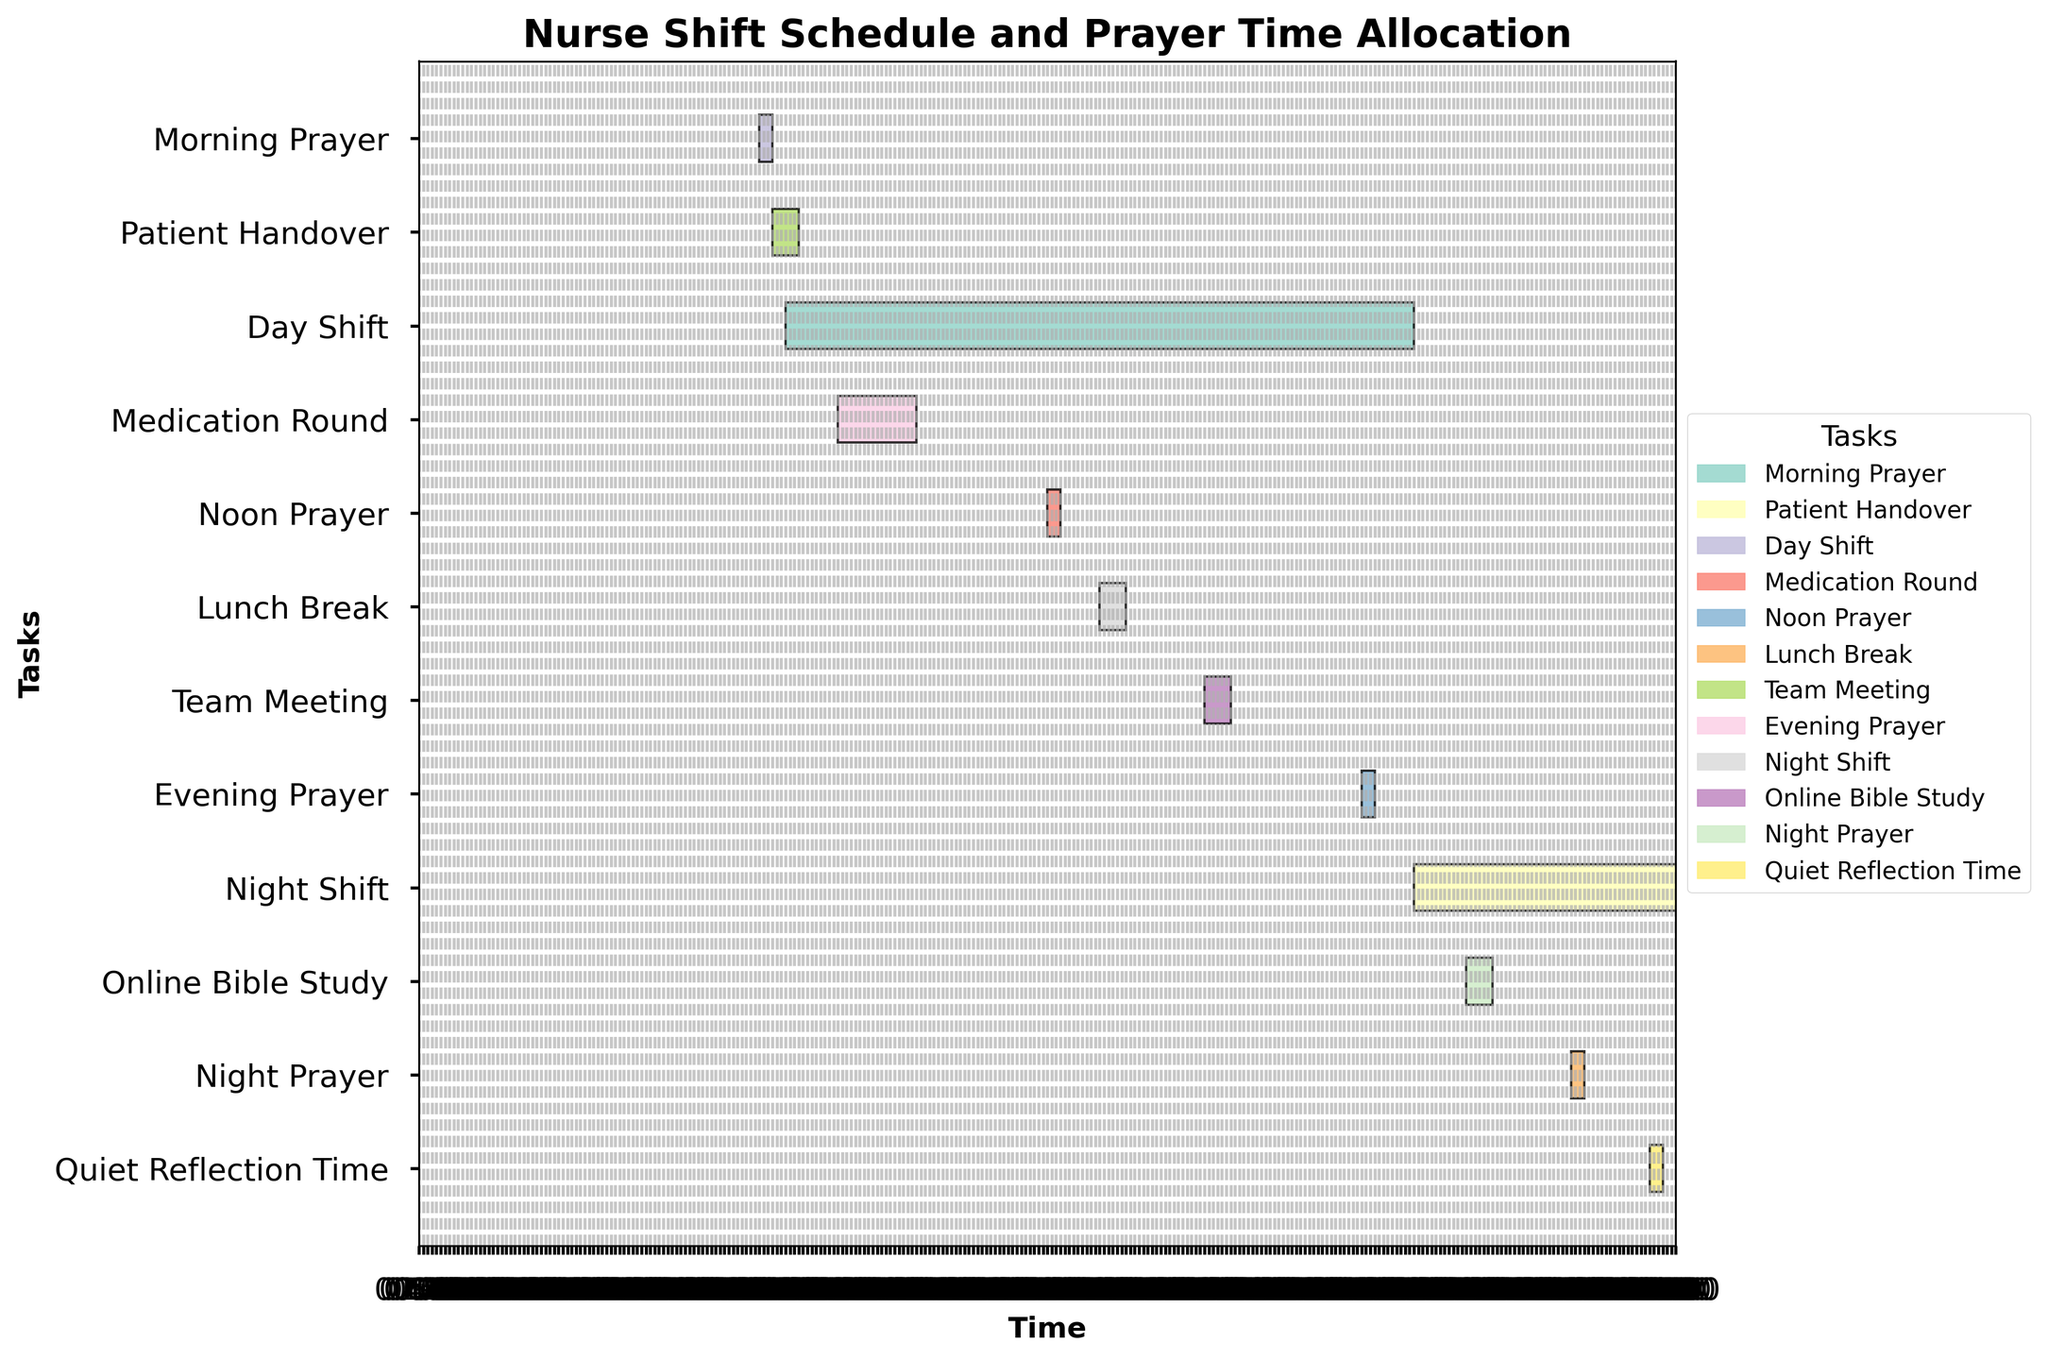What are the start and end times for the day shift? The figure shows a bar labeled 'Day Shift' starting at 07:00 and ending at 19:00.
Answer: 07:00 to 19:00 How long is the night prayer? To find the duration, subtract the start time (22:00) from the end time (22:15). This gives 15 minutes.
Answer: 15 minutes Which prayer time overlaps with the end of the day shift? The day shift ends at 19:00. The Evening Prayer starts at 18:00 and ends at 18:15, which does not overlap. No prayer time overlaps with the end of the day shift.
Answer: None Which task starts immediately after the morning prayer? The morning prayer ends at 06:45. Checking the tasks, 'Patient Handover' starts at 06:45.
Answer: Patient Handover How does the duration of the medication round compare with the team meeting? Medication Round starts at 08:00 and ends at 09:30 (1.5 hours). Team Meeting starts at 15:00 and ends at 15:30 (0.5 hours). Comparison: 1.5 hours is greater than 0.5 hours.
Answer: Medication Round is longer How many tasks take place between noon prayer and night prayer? Noon Prayer is from 12:00 to 12:15 and Night Prayer is from 22:00 to 22:15. Between these times, the tasks are: Lunch Break, Team Meeting, and Online Bible Study.
Answer: 3 tasks Which task extends overnight? Tasks that extend past midnight will have end times that are before their start times. 'Night Shift' starts at 19:00 and ends at 07:00 the next day.
Answer: Night Shift What is the shortest prayer time shown in the chart? The prayer times are 15 minutes each: Morning Prayer (06:30-06:45), Noon Prayer (12:00-12:15), Evening Prayer (18:00-18:15), Night Prayer (22:00-22:15). All have the same duration.
Answer: All prayers have the same duration When is the online bible study scheduled? The chart shows 'Online Bible Study' scheduled from 20:00 to 20:30.
Answer: 20:00 to 20:30 